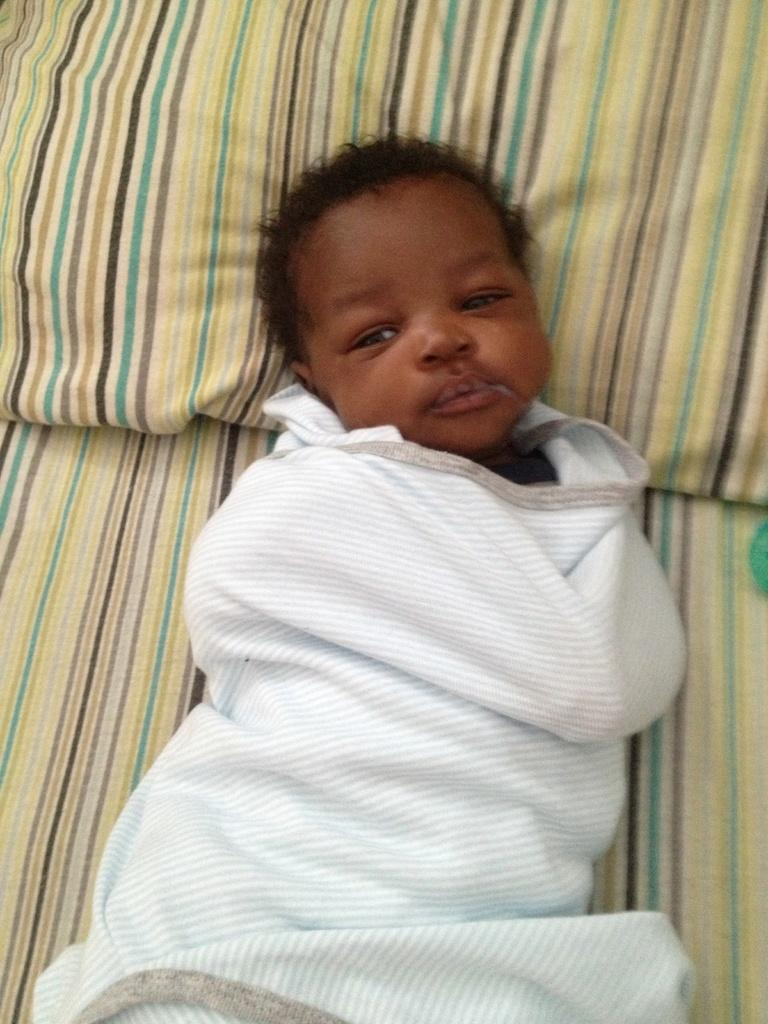What is the main subject of the image? There is a baby in the image. Where is the baby located? The baby is lying on a bed. How is the baby dressed or covered in the image? The baby is wrapped in a cloth. What is the baby using to support its head? The baby is resting his head on a pillow. Is the baby stuck in quicksand in the image? No, there is no quicksand present in the image. The baby is lying on a bed, wrapped in a cloth, and resting its head on a pillow. 